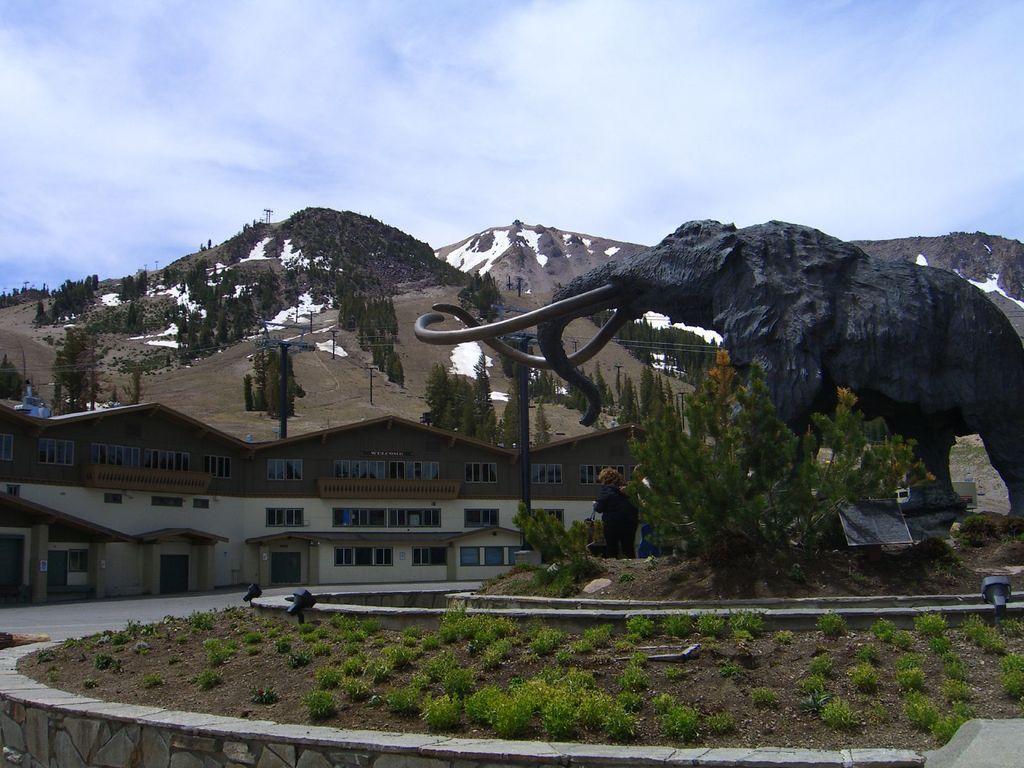Describe this image in one or two sentences. In this picture we can see a statue on the right side, at the bottom there are some plants, we can see hills, trees and a building in the background, there are two persons standing in the middle, we can see the sky at the top of the picture. 